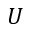Convert formula to latex. <formula><loc_0><loc_0><loc_500><loc_500>U</formula> 